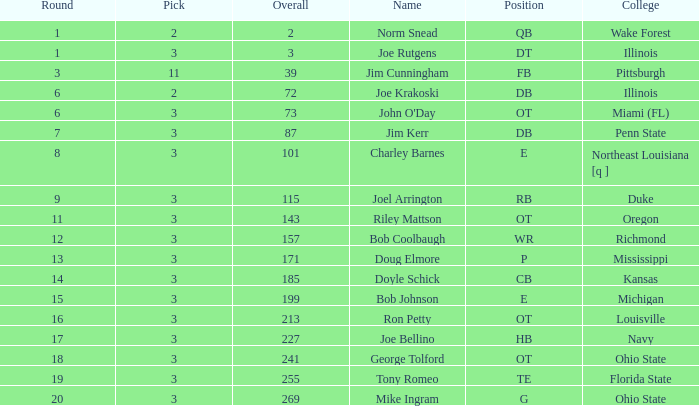In how many rounds does john o'day have the name, with a selection below 3? None. Parse the table in full. {'header': ['Round', 'Pick', 'Overall', 'Name', 'Position', 'College'], 'rows': [['1', '2', '2', 'Norm Snead', 'QB', 'Wake Forest'], ['1', '3', '3', 'Joe Rutgens', 'DT', 'Illinois'], ['3', '11', '39', 'Jim Cunningham', 'FB', 'Pittsburgh'], ['6', '2', '72', 'Joe Krakoski', 'DB', 'Illinois'], ['6', '3', '73', "John O'Day", 'OT', 'Miami (FL)'], ['7', '3', '87', 'Jim Kerr', 'DB', 'Penn State'], ['8', '3', '101', 'Charley Barnes', 'E', 'Northeast Louisiana [q ]'], ['9', '3', '115', 'Joel Arrington', 'RB', 'Duke'], ['11', '3', '143', 'Riley Mattson', 'OT', 'Oregon'], ['12', '3', '157', 'Bob Coolbaugh', 'WR', 'Richmond'], ['13', '3', '171', 'Doug Elmore', 'P', 'Mississippi'], ['14', '3', '185', 'Doyle Schick', 'CB', 'Kansas'], ['15', '3', '199', 'Bob Johnson', 'E', 'Michigan'], ['16', '3', '213', 'Ron Petty', 'OT', 'Louisville'], ['17', '3', '227', 'Joe Bellino', 'HB', 'Navy'], ['18', '3', '241', 'George Tolford', 'OT', 'Ohio State'], ['19', '3', '255', 'Tony Romeo', 'TE', 'Florida State'], ['20', '3', '269', 'Mike Ingram', 'G', 'Ohio State']]} 